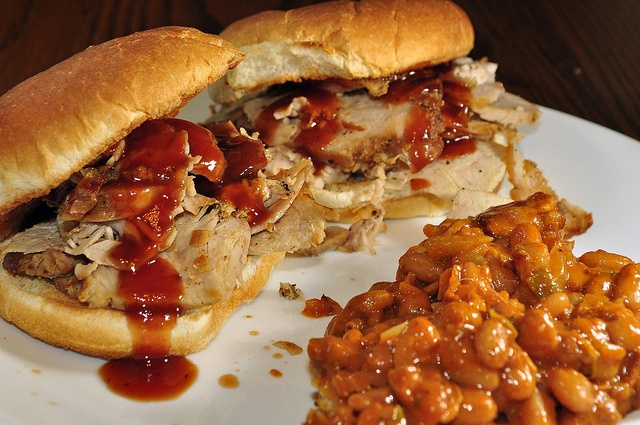Describe the objects in this image and their specific colors. I can see sandwich in black, brown, tan, and maroon tones, sandwich in black, brown, tan, and maroon tones, and dining table in black, maroon, and brown tones in this image. 